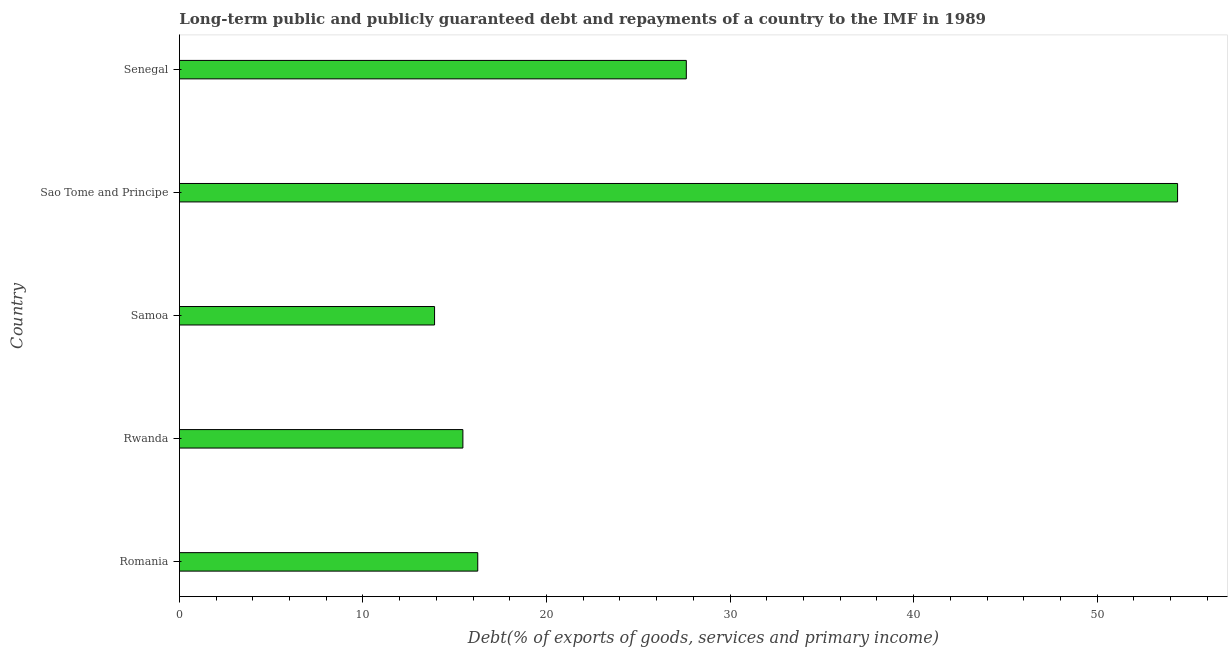What is the title of the graph?
Your response must be concise. Long-term public and publicly guaranteed debt and repayments of a country to the IMF in 1989. What is the label or title of the X-axis?
Make the answer very short. Debt(% of exports of goods, services and primary income). What is the label or title of the Y-axis?
Offer a very short reply. Country. What is the debt service in Romania?
Make the answer very short. 16.25. Across all countries, what is the maximum debt service?
Make the answer very short. 54.38. Across all countries, what is the minimum debt service?
Your answer should be very brief. 13.9. In which country was the debt service maximum?
Your answer should be very brief. Sao Tome and Principe. In which country was the debt service minimum?
Provide a short and direct response. Samoa. What is the sum of the debt service?
Ensure brevity in your answer.  127.59. What is the difference between the debt service in Romania and Rwanda?
Provide a succinct answer. 0.81. What is the average debt service per country?
Your response must be concise. 25.52. What is the median debt service?
Make the answer very short. 16.25. In how many countries, is the debt service greater than 44 %?
Your answer should be very brief. 1. What is the ratio of the debt service in Rwanda to that in Samoa?
Provide a succinct answer. 1.11. What is the difference between the highest and the second highest debt service?
Provide a succinct answer. 26.76. Is the sum of the debt service in Romania and Samoa greater than the maximum debt service across all countries?
Provide a short and direct response. No. What is the difference between the highest and the lowest debt service?
Offer a very short reply. 40.48. In how many countries, is the debt service greater than the average debt service taken over all countries?
Keep it short and to the point. 2. What is the difference between two consecutive major ticks on the X-axis?
Your response must be concise. 10. Are the values on the major ticks of X-axis written in scientific E-notation?
Provide a succinct answer. No. What is the Debt(% of exports of goods, services and primary income) of Romania?
Keep it short and to the point. 16.25. What is the Debt(% of exports of goods, services and primary income) in Rwanda?
Offer a very short reply. 15.44. What is the Debt(% of exports of goods, services and primary income) in Samoa?
Your answer should be very brief. 13.9. What is the Debt(% of exports of goods, services and primary income) of Sao Tome and Principe?
Make the answer very short. 54.38. What is the Debt(% of exports of goods, services and primary income) in Senegal?
Your answer should be very brief. 27.62. What is the difference between the Debt(% of exports of goods, services and primary income) in Romania and Rwanda?
Your answer should be compact. 0.81. What is the difference between the Debt(% of exports of goods, services and primary income) in Romania and Samoa?
Your response must be concise. 2.35. What is the difference between the Debt(% of exports of goods, services and primary income) in Romania and Sao Tome and Principe?
Your answer should be compact. -38.13. What is the difference between the Debt(% of exports of goods, services and primary income) in Romania and Senegal?
Provide a short and direct response. -11.36. What is the difference between the Debt(% of exports of goods, services and primary income) in Rwanda and Samoa?
Your answer should be very brief. 1.54. What is the difference between the Debt(% of exports of goods, services and primary income) in Rwanda and Sao Tome and Principe?
Make the answer very short. -38.94. What is the difference between the Debt(% of exports of goods, services and primary income) in Rwanda and Senegal?
Give a very brief answer. -12.17. What is the difference between the Debt(% of exports of goods, services and primary income) in Samoa and Sao Tome and Principe?
Make the answer very short. -40.48. What is the difference between the Debt(% of exports of goods, services and primary income) in Samoa and Senegal?
Keep it short and to the point. -13.72. What is the difference between the Debt(% of exports of goods, services and primary income) in Sao Tome and Principe and Senegal?
Keep it short and to the point. 26.76. What is the ratio of the Debt(% of exports of goods, services and primary income) in Romania to that in Rwanda?
Your answer should be very brief. 1.05. What is the ratio of the Debt(% of exports of goods, services and primary income) in Romania to that in Samoa?
Ensure brevity in your answer.  1.17. What is the ratio of the Debt(% of exports of goods, services and primary income) in Romania to that in Sao Tome and Principe?
Offer a very short reply. 0.3. What is the ratio of the Debt(% of exports of goods, services and primary income) in Romania to that in Senegal?
Offer a terse response. 0.59. What is the ratio of the Debt(% of exports of goods, services and primary income) in Rwanda to that in Samoa?
Provide a short and direct response. 1.11. What is the ratio of the Debt(% of exports of goods, services and primary income) in Rwanda to that in Sao Tome and Principe?
Keep it short and to the point. 0.28. What is the ratio of the Debt(% of exports of goods, services and primary income) in Rwanda to that in Senegal?
Your response must be concise. 0.56. What is the ratio of the Debt(% of exports of goods, services and primary income) in Samoa to that in Sao Tome and Principe?
Provide a short and direct response. 0.26. What is the ratio of the Debt(% of exports of goods, services and primary income) in Samoa to that in Senegal?
Your answer should be very brief. 0.5. What is the ratio of the Debt(% of exports of goods, services and primary income) in Sao Tome and Principe to that in Senegal?
Provide a succinct answer. 1.97. 